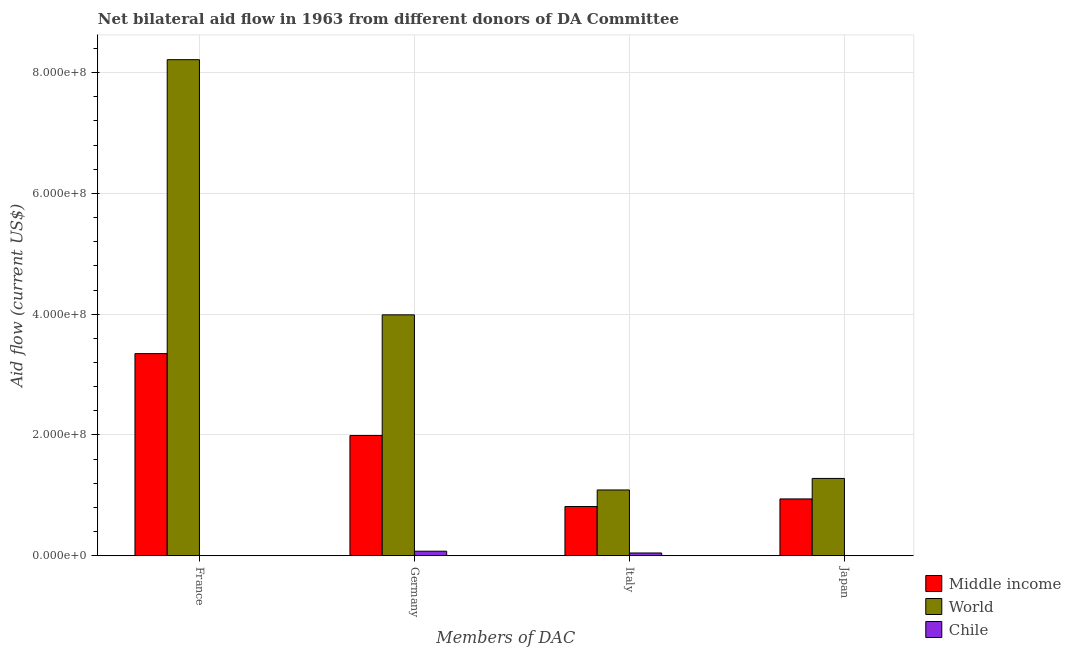How many different coloured bars are there?
Offer a very short reply. 3. Are the number of bars on each tick of the X-axis equal?
Your response must be concise. Yes. How many bars are there on the 3rd tick from the left?
Ensure brevity in your answer.  3. What is the amount of aid given by germany in Middle income?
Your answer should be very brief. 1.99e+08. Across all countries, what is the maximum amount of aid given by japan?
Provide a succinct answer. 1.28e+08. Across all countries, what is the minimum amount of aid given by italy?
Give a very brief answer. 4.66e+06. What is the total amount of aid given by japan in the graph?
Your answer should be very brief. 2.22e+08. What is the difference between the amount of aid given by germany in Middle income and that in World?
Your answer should be very brief. -2.00e+08. What is the difference between the amount of aid given by italy in Chile and the amount of aid given by japan in World?
Provide a short and direct response. -1.23e+08. What is the average amount of aid given by japan per country?
Offer a very short reply. 7.41e+07. What is the difference between the amount of aid given by japan and amount of aid given by italy in Middle income?
Provide a short and direct response. 1.26e+07. In how many countries, is the amount of aid given by germany greater than 200000000 US$?
Keep it short and to the point. 1. Is the amount of aid given by japan in World less than that in Chile?
Keep it short and to the point. No. What is the difference between the highest and the second highest amount of aid given by italy?
Offer a terse response. 2.74e+07. What is the difference between the highest and the lowest amount of aid given by japan?
Provide a short and direct response. 1.28e+08. In how many countries, is the amount of aid given by france greater than the average amount of aid given by france taken over all countries?
Your answer should be very brief. 1. Is the sum of the amount of aid given by japan in Middle income and World greater than the maximum amount of aid given by germany across all countries?
Make the answer very short. No. Is it the case that in every country, the sum of the amount of aid given by japan and amount of aid given by germany is greater than the sum of amount of aid given by italy and amount of aid given by france?
Your answer should be compact. No. What does the 1st bar from the left in Italy represents?
Make the answer very short. Middle income. Are all the bars in the graph horizontal?
Offer a terse response. No. How many countries are there in the graph?
Offer a very short reply. 3. What is the difference between two consecutive major ticks on the Y-axis?
Your response must be concise. 2.00e+08. Does the graph contain any zero values?
Provide a short and direct response. No. Does the graph contain grids?
Keep it short and to the point. Yes. Where does the legend appear in the graph?
Provide a short and direct response. Bottom right. How are the legend labels stacked?
Provide a short and direct response. Vertical. What is the title of the graph?
Keep it short and to the point. Net bilateral aid flow in 1963 from different donors of DA Committee. Does "Virgin Islands" appear as one of the legend labels in the graph?
Offer a very short reply. No. What is the label or title of the X-axis?
Provide a succinct answer. Members of DAC. What is the Aid flow (current US$) in Middle income in France?
Your response must be concise. 3.35e+08. What is the Aid flow (current US$) in World in France?
Your response must be concise. 8.21e+08. What is the Aid flow (current US$) in Middle income in Germany?
Provide a succinct answer. 1.99e+08. What is the Aid flow (current US$) of World in Germany?
Keep it short and to the point. 3.99e+08. What is the Aid flow (current US$) in Chile in Germany?
Offer a terse response. 7.58e+06. What is the Aid flow (current US$) in Middle income in Italy?
Make the answer very short. 8.16e+07. What is the Aid flow (current US$) of World in Italy?
Keep it short and to the point. 1.09e+08. What is the Aid flow (current US$) in Chile in Italy?
Your response must be concise. 4.66e+06. What is the Aid flow (current US$) in Middle income in Japan?
Ensure brevity in your answer.  9.42e+07. What is the Aid flow (current US$) of World in Japan?
Provide a short and direct response. 1.28e+08. What is the Aid flow (current US$) of Chile in Japan?
Make the answer very short. 3.00e+04. Across all Members of DAC, what is the maximum Aid flow (current US$) in Middle income?
Your response must be concise. 3.35e+08. Across all Members of DAC, what is the maximum Aid flow (current US$) in World?
Your answer should be very brief. 8.21e+08. Across all Members of DAC, what is the maximum Aid flow (current US$) in Chile?
Make the answer very short. 7.58e+06. Across all Members of DAC, what is the minimum Aid flow (current US$) in Middle income?
Keep it short and to the point. 8.16e+07. Across all Members of DAC, what is the minimum Aid flow (current US$) of World?
Give a very brief answer. 1.09e+08. Across all Members of DAC, what is the minimum Aid flow (current US$) of Chile?
Offer a very short reply. 3.00e+04. What is the total Aid flow (current US$) in Middle income in the graph?
Provide a short and direct response. 7.10e+08. What is the total Aid flow (current US$) in World in the graph?
Your answer should be compact. 1.46e+09. What is the total Aid flow (current US$) in Chile in the graph?
Provide a short and direct response. 1.26e+07. What is the difference between the Aid flow (current US$) in Middle income in France and that in Germany?
Give a very brief answer. 1.36e+08. What is the difference between the Aid flow (current US$) of World in France and that in Germany?
Ensure brevity in your answer.  4.22e+08. What is the difference between the Aid flow (current US$) in Chile in France and that in Germany?
Give a very brief answer. -7.28e+06. What is the difference between the Aid flow (current US$) of Middle income in France and that in Italy?
Provide a short and direct response. 2.53e+08. What is the difference between the Aid flow (current US$) of World in France and that in Italy?
Give a very brief answer. 7.12e+08. What is the difference between the Aid flow (current US$) of Chile in France and that in Italy?
Ensure brevity in your answer.  -4.36e+06. What is the difference between the Aid flow (current US$) in Middle income in France and that in Japan?
Your response must be concise. 2.41e+08. What is the difference between the Aid flow (current US$) of World in France and that in Japan?
Keep it short and to the point. 6.93e+08. What is the difference between the Aid flow (current US$) in Middle income in Germany and that in Italy?
Keep it short and to the point. 1.18e+08. What is the difference between the Aid flow (current US$) of World in Germany and that in Italy?
Offer a very short reply. 2.90e+08. What is the difference between the Aid flow (current US$) in Chile in Germany and that in Italy?
Keep it short and to the point. 2.92e+06. What is the difference between the Aid flow (current US$) of Middle income in Germany and that in Japan?
Make the answer very short. 1.05e+08. What is the difference between the Aid flow (current US$) in World in Germany and that in Japan?
Give a very brief answer. 2.71e+08. What is the difference between the Aid flow (current US$) in Chile in Germany and that in Japan?
Provide a short and direct response. 7.55e+06. What is the difference between the Aid flow (current US$) of Middle income in Italy and that in Japan?
Make the answer very short. -1.26e+07. What is the difference between the Aid flow (current US$) of World in Italy and that in Japan?
Offer a very short reply. -1.91e+07. What is the difference between the Aid flow (current US$) in Chile in Italy and that in Japan?
Make the answer very short. 4.63e+06. What is the difference between the Aid flow (current US$) in Middle income in France and the Aid flow (current US$) in World in Germany?
Provide a succinct answer. -6.42e+07. What is the difference between the Aid flow (current US$) of Middle income in France and the Aid flow (current US$) of Chile in Germany?
Your answer should be very brief. 3.27e+08. What is the difference between the Aid flow (current US$) in World in France and the Aid flow (current US$) in Chile in Germany?
Keep it short and to the point. 8.14e+08. What is the difference between the Aid flow (current US$) of Middle income in France and the Aid flow (current US$) of World in Italy?
Your answer should be compact. 2.26e+08. What is the difference between the Aid flow (current US$) in Middle income in France and the Aid flow (current US$) in Chile in Italy?
Your response must be concise. 3.30e+08. What is the difference between the Aid flow (current US$) in World in France and the Aid flow (current US$) in Chile in Italy?
Your answer should be very brief. 8.17e+08. What is the difference between the Aid flow (current US$) of Middle income in France and the Aid flow (current US$) of World in Japan?
Your answer should be very brief. 2.07e+08. What is the difference between the Aid flow (current US$) in Middle income in France and the Aid flow (current US$) in Chile in Japan?
Offer a terse response. 3.35e+08. What is the difference between the Aid flow (current US$) in World in France and the Aid flow (current US$) in Chile in Japan?
Your answer should be compact. 8.21e+08. What is the difference between the Aid flow (current US$) in Middle income in Germany and the Aid flow (current US$) in World in Italy?
Your response must be concise. 9.02e+07. What is the difference between the Aid flow (current US$) in Middle income in Germany and the Aid flow (current US$) in Chile in Italy?
Ensure brevity in your answer.  1.95e+08. What is the difference between the Aid flow (current US$) of World in Germany and the Aid flow (current US$) of Chile in Italy?
Keep it short and to the point. 3.94e+08. What is the difference between the Aid flow (current US$) in Middle income in Germany and the Aid flow (current US$) in World in Japan?
Your response must be concise. 7.11e+07. What is the difference between the Aid flow (current US$) in Middle income in Germany and the Aid flow (current US$) in Chile in Japan?
Make the answer very short. 1.99e+08. What is the difference between the Aid flow (current US$) of World in Germany and the Aid flow (current US$) of Chile in Japan?
Give a very brief answer. 3.99e+08. What is the difference between the Aid flow (current US$) of Middle income in Italy and the Aid flow (current US$) of World in Japan?
Your answer should be compact. -4.66e+07. What is the difference between the Aid flow (current US$) in Middle income in Italy and the Aid flow (current US$) in Chile in Japan?
Ensure brevity in your answer.  8.15e+07. What is the difference between the Aid flow (current US$) in World in Italy and the Aid flow (current US$) in Chile in Japan?
Your response must be concise. 1.09e+08. What is the average Aid flow (current US$) in Middle income per Members of DAC?
Your answer should be compact. 1.77e+08. What is the average Aid flow (current US$) in World per Members of DAC?
Provide a succinct answer. 3.64e+08. What is the average Aid flow (current US$) of Chile per Members of DAC?
Offer a very short reply. 3.14e+06. What is the difference between the Aid flow (current US$) in Middle income and Aid flow (current US$) in World in France?
Give a very brief answer. -4.87e+08. What is the difference between the Aid flow (current US$) of Middle income and Aid flow (current US$) of Chile in France?
Offer a terse response. 3.34e+08. What is the difference between the Aid flow (current US$) of World and Aid flow (current US$) of Chile in France?
Your answer should be very brief. 8.21e+08. What is the difference between the Aid flow (current US$) of Middle income and Aid flow (current US$) of World in Germany?
Give a very brief answer. -2.00e+08. What is the difference between the Aid flow (current US$) in Middle income and Aid flow (current US$) in Chile in Germany?
Offer a very short reply. 1.92e+08. What is the difference between the Aid flow (current US$) in World and Aid flow (current US$) in Chile in Germany?
Provide a succinct answer. 3.91e+08. What is the difference between the Aid flow (current US$) in Middle income and Aid flow (current US$) in World in Italy?
Give a very brief answer. -2.74e+07. What is the difference between the Aid flow (current US$) of Middle income and Aid flow (current US$) of Chile in Italy?
Your answer should be very brief. 7.69e+07. What is the difference between the Aid flow (current US$) in World and Aid flow (current US$) in Chile in Italy?
Offer a very short reply. 1.04e+08. What is the difference between the Aid flow (current US$) of Middle income and Aid flow (current US$) of World in Japan?
Your answer should be compact. -3.40e+07. What is the difference between the Aid flow (current US$) of Middle income and Aid flow (current US$) of Chile in Japan?
Provide a succinct answer. 9.41e+07. What is the difference between the Aid flow (current US$) in World and Aid flow (current US$) in Chile in Japan?
Your response must be concise. 1.28e+08. What is the ratio of the Aid flow (current US$) of Middle income in France to that in Germany?
Provide a short and direct response. 1.68. What is the ratio of the Aid flow (current US$) in World in France to that in Germany?
Provide a short and direct response. 2.06. What is the ratio of the Aid flow (current US$) in Chile in France to that in Germany?
Your answer should be very brief. 0.04. What is the ratio of the Aid flow (current US$) of Middle income in France to that in Italy?
Your answer should be compact. 4.1. What is the ratio of the Aid flow (current US$) of World in France to that in Italy?
Keep it short and to the point. 7.54. What is the ratio of the Aid flow (current US$) of Chile in France to that in Italy?
Your response must be concise. 0.06. What is the ratio of the Aid flow (current US$) of Middle income in France to that in Japan?
Keep it short and to the point. 3.56. What is the ratio of the Aid flow (current US$) in World in France to that in Japan?
Make the answer very short. 6.41. What is the ratio of the Aid flow (current US$) in Middle income in Germany to that in Italy?
Your answer should be compact. 2.44. What is the ratio of the Aid flow (current US$) in World in Germany to that in Italy?
Your response must be concise. 3.66. What is the ratio of the Aid flow (current US$) in Chile in Germany to that in Italy?
Provide a short and direct response. 1.63. What is the ratio of the Aid flow (current US$) in Middle income in Germany to that in Japan?
Make the answer very short. 2.12. What is the ratio of the Aid flow (current US$) in World in Germany to that in Japan?
Keep it short and to the point. 3.11. What is the ratio of the Aid flow (current US$) in Chile in Germany to that in Japan?
Offer a terse response. 252.67. What is the ratio of the Aid flow (current US$) of Middle income in Italy to that in Japan?
Your answer should be very brief. 0.87. What is the ratio of the Aid flow (current US$) in World in Italy to that in Japan?
Offer a terse response. 0.85. What is the ratio of the Aid flow (current US$) in Chile in Italy to that in Japan?
Provide a succinct answer. 155.33. What is the difference between the highest and the second highest Aid flow (current US$) of Middle income?
Your answer should be compact. 1.36e+08. What is the difference between the highest and the second highest Aid flow (current US$) of World?
Provide a succinct answer. 4.22e+08. What is the difference between the highest and the second highest Aid flow (current US$) of Chile?
Keep it short and to the point. 2.92e+06. What is the difference between the highest and the lowest Aid flow (current US$) of Middle income?
Your answer should be very brief. 2.53e+08. What is the difference between the highest and the lowest Aid flow (current US$) of World?
Provide a short and direct response. 7.12e+08. What is the difference between the highest and the lowest Aid flow (current US$) of Chile?
Keep it short and to the point. 7.55e+06. 